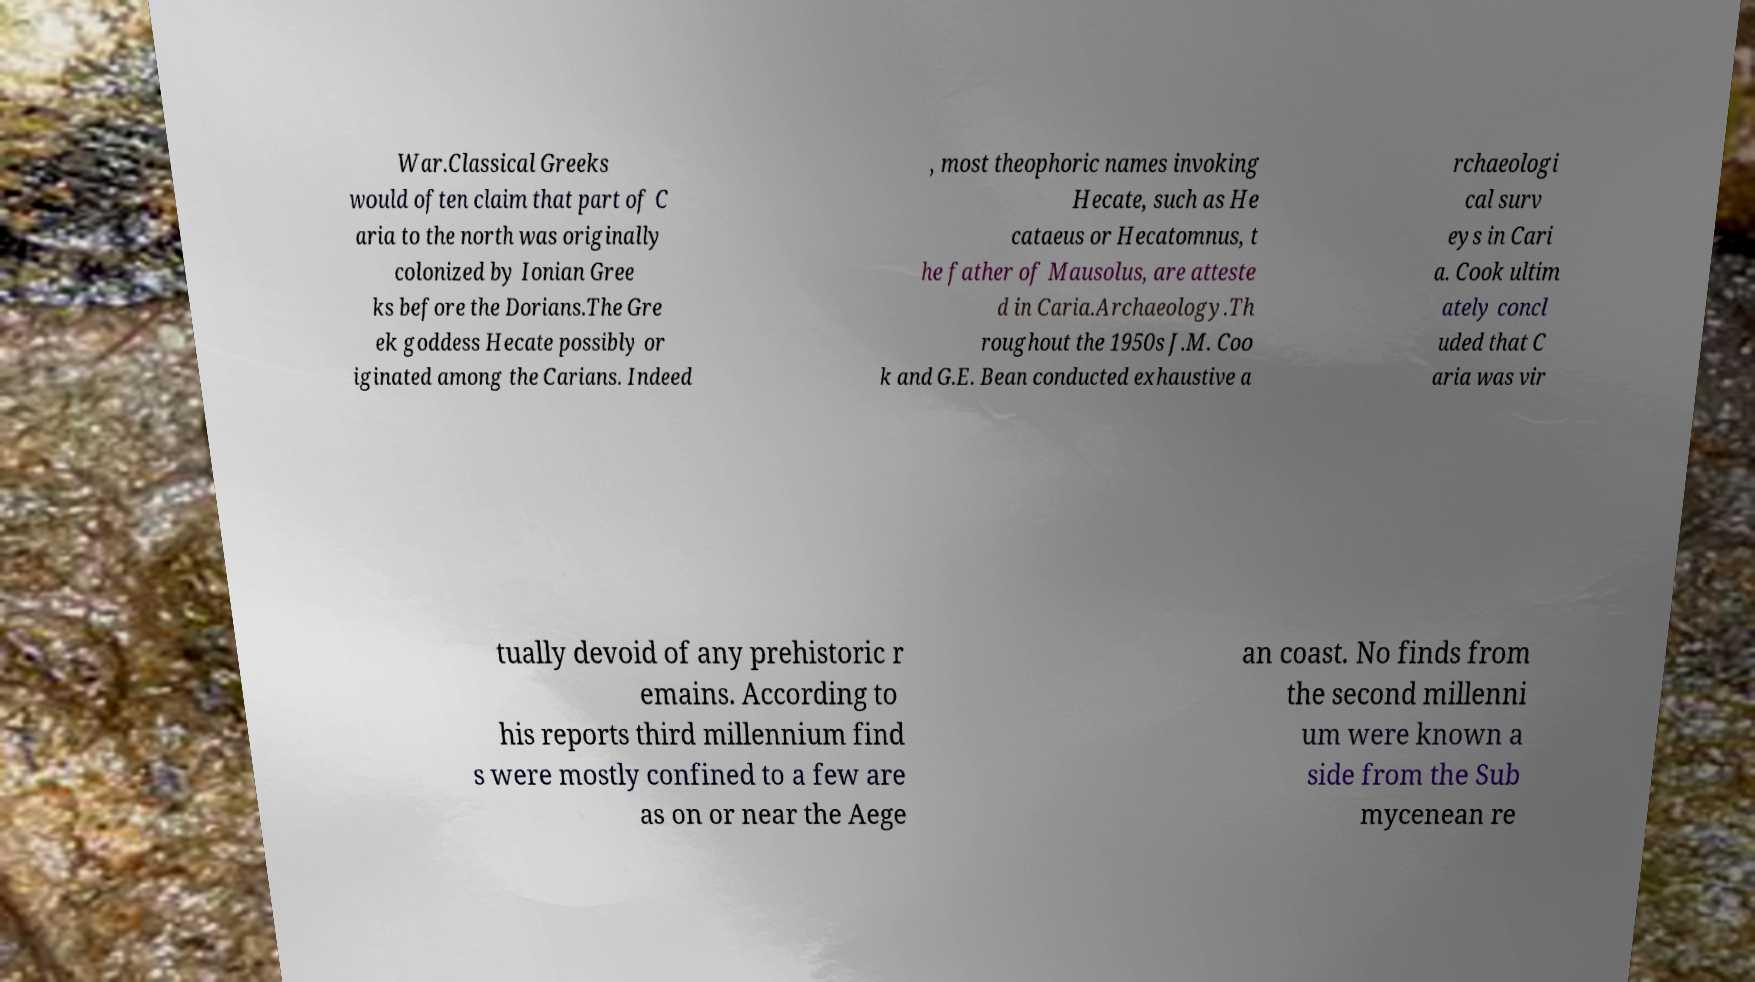Please identify and transcribe the text found in this image. War.Classical Greeks would often claim that part of C aria to the north was originally colonized by Ionian Gree ks before the Dorians.The Gre ek goddess Hecate possibly or iginated among the Carians. Indeed , most theophoric names invoking Hecate, such as He cataeus or Hecatomnus, t he father of Mausolus, are atteste d in Caria.Archaeology.Th roughout the 1950s J.M. Coo k and G.E. Bean conducted exhaustive a rchaeologi cal surv eys in Cari a. Cook ultim ately concl uded that C aria was vir tually devoid of any prehistoric r emains. According to his reports third millennium find s were mostly confined to a few are as on or near the Aege an coast. No finds from the second millenni um were known a side from the Sub mycenean re 